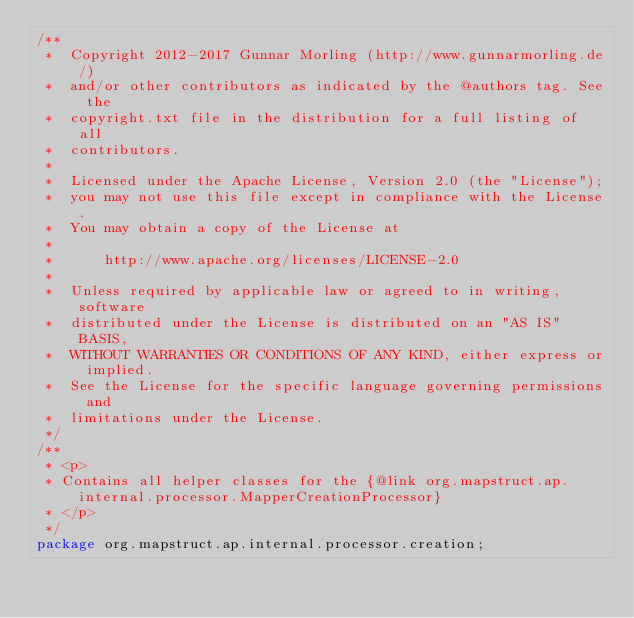<code> <loc_0><loc_0><loc_500><loc_500><_Java_>/**
 *  Copyright 2012-2017 Gunnar Morling (http://www.gunnarmorling.de/)
 *  and/or other contributors as indicated by the @authors tag. See the
 *  copyright.txt file in the distribution for a full listing of all
 *  contributors.
 *
 *  Licensed under the Apache License, Version 2.0 (the "License");
 *  you may not use this file except in compliance with the License.
 *  You may obtain a copy of the License at
 *
 *      http://www.apache.org/licenses/LICENSE-2.0
 *
 *  Unless required by applicable law or agreed to in writing, software
 *  distributed under the License is distributed on an "AS IS" BASIS,
 *  WITHOUT WARRANTIES OR CONDITIONS OF ANY KIND, either express or implied.
 *  See the License for the specific language governing permissions and
 *  limitations under the License.
 */
/**
 * <p>
 * Contains all helper classes for the {@link org.mapstruct.ap.internal.processor.MapperCreationProcessor}
 * </p>
 */
package org.mapstruct.ap.internal.processor.creation;
</code> 